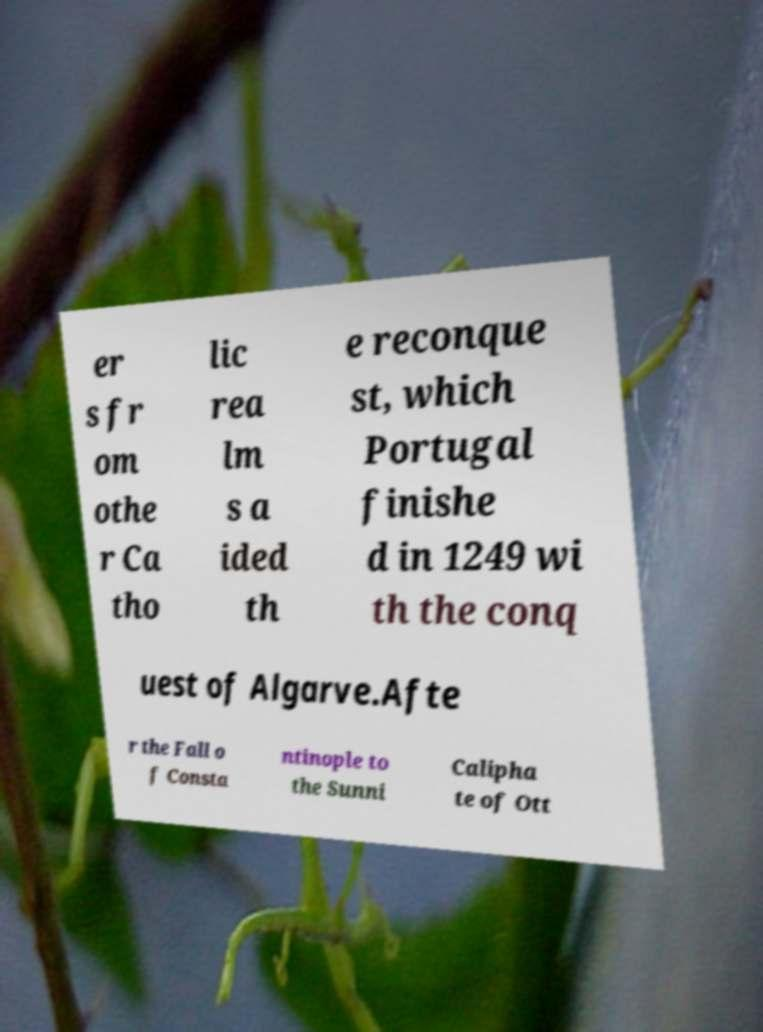I need the written content from this picture converted into text. Can you do that? er s fr om othe r Ca tho lic rea lm s a ided th e reconque st, which Portugal finishe d in 1249 wi th the conq uest of Algarve.Afte r the Fall o f Consta ntinople to the Sunni Calipha te of Ott 